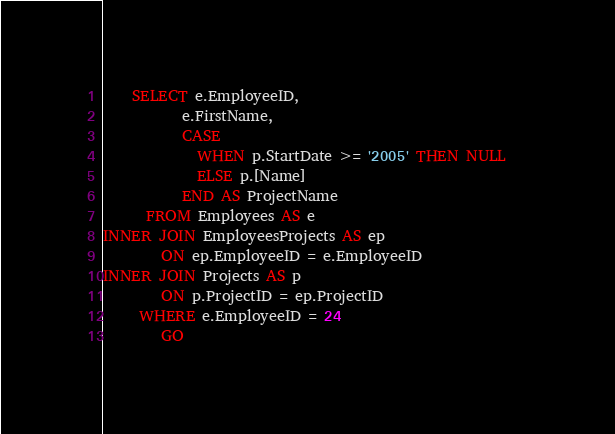<code> <loc_0><loc_0><loc_500><loc_500><_SQL_>    SELECT e.EmployeeID,
	       e.FirstName,
		   CASE   
             WHEN p.StartDate >= '2005' THEN NULL   
             ELSE p.[Name] 
           END AS ProjectName
      FROM Employees AS e
INNER JOIN EmployeesProjects AS ep
        ON ep.EmployeeID = e.EmployeeID
INNER JOIN Projects AS p
        ON p.ProjectID = ep.ProjectID
	 WHERE e.EmployeeID = 24
	    GO</code> 